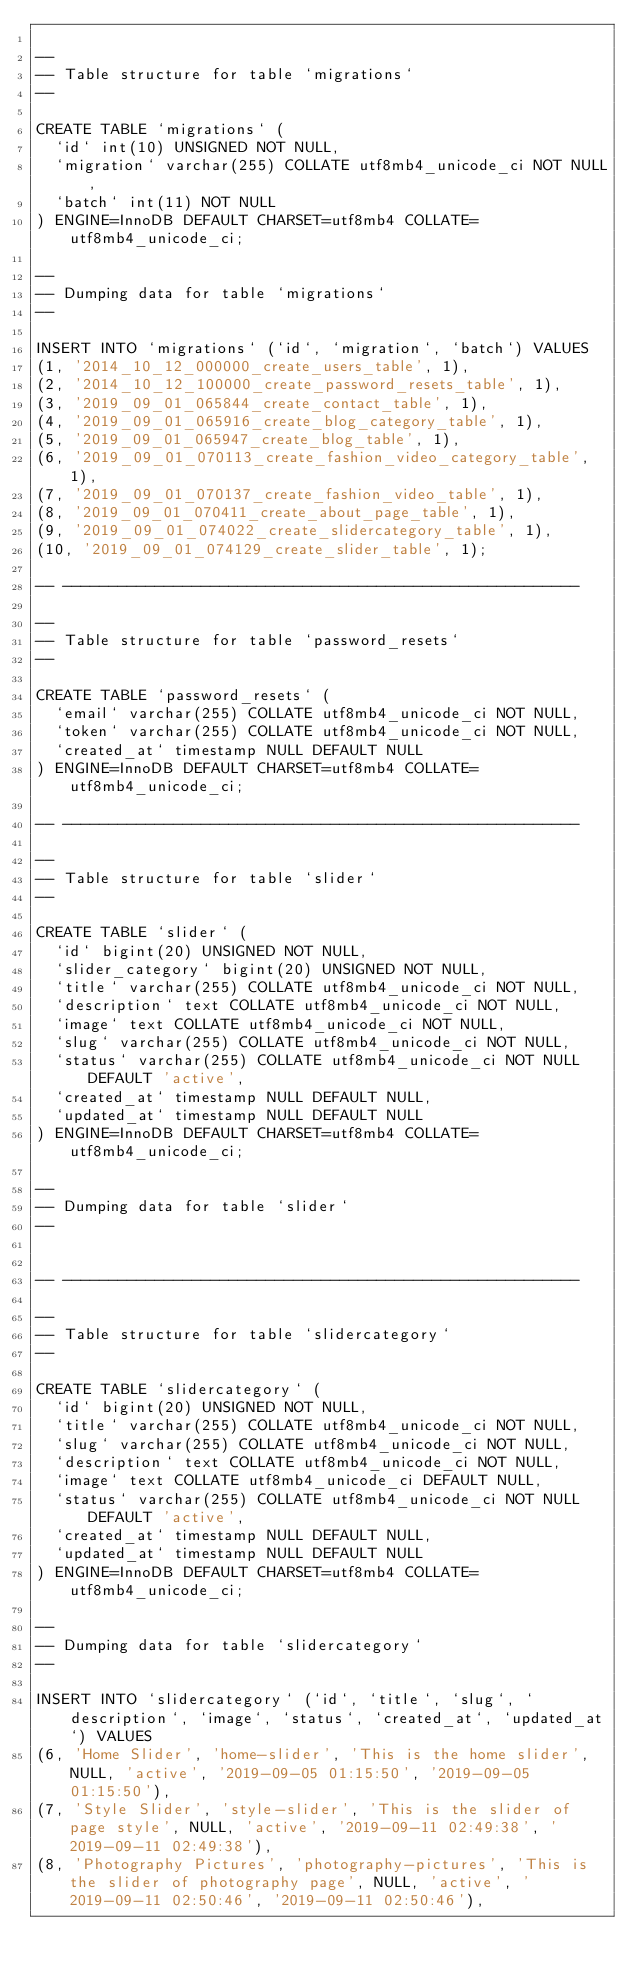<code> <loc_0><loc_0><loc_500><loc_500><_SQL_>
--
-- Table structure for table `migrations`
--

CREATE TABLE `migrations` (
  `id` int(10) UNSIGNED NOT NULL,
  `migration` varchar(255) COLLATE utf8mb4_unicode_ci NOT NULL,
  `batch` int(11) NOT NULL
) ENGINE=InnoDB DEFAULT CHARSET=utf8mb4 COLLATE=utf8mb4_unicode_ci;

--
-- Dumping data for table `migrations`
--

INSERT INTO `migrations` (`id`, `migration`, `batch`) VALUES
(1, '2014_10_12_000000_create_users_table', 1),
(2, '2014_10_12_100000_create_password_resets_table', 1),
(3, '2019_09_01_065844_create_contact_table', 1),
(4, '2019_09_01_065916_create_blog_category_table', 1),
(5, '2019_09_01_065947_create_blog_table', 1),
(6, '2019_09_01_070113_create_fashion_video_category_table', 1),
(7, '2019_09_01_070137_create_fashion_video_table', 1),
(8, '2019_09_01_070411_create_about_page_table', 1),
(9, '2019_09_01_074022_create_slidercategory_table', 1),
(10, '2019_09_01_074129_create_slider_table', 1);

-- --------------------------------------------------------

--
-- Table structure for table `password_resets`
--

CREATE TABLE `password_resets` (
  `email` varchar(255) COLLATE utf8mb4_unicode_ci NOT NULL,
  `token` varchar(255) COLLATE utf8mb4_unicode_ci NOT NULL,
  `created_at` timestamp NULL DEFAULT NULL
) ENGINE=InnoDB DEFAULT CHARSET=utf8mb4 COLLATE=utf8mb4_unicode_ci;

-- --------------------------------------------------------

--
-- Table structure for table `slider`
--

CREATE TABLE `slider` (
  `id` bigint(20) UNSIGNED NOT NULL,
  `slider_category` bigint(20) UNSIGNED NOT NULL,
  `title` varchar(255) COLLATE utf8mb4_unicode_ci NOT NULL,
  `description` text COLLATE utf8mb4_unicode_ci NOT NULL,
  `image` text COLLATE utf8mb4_unicode_ci NOT NULL,
  `slug` varchar(255) COLLATE utf8mb4_unicode_ci NOT NULL,
  `status` varchar(255) COLLATE utf8mb4_unicode_ci NOT NULL DEFAULT 'active',
  `created_at` timestamp NULL DEFAULT NULL,
  `updated_at` timestamp NULL DEFAULT NULL
) ENGINE=InnoDB DEFAULT CHARSET=utf8mb4 COLLATE=utf8mb4_unicode_ci;

--
-- Dumping data for table `slider`
--


-- --------------------------------------------------------

--
-- Table structure for table `slidercategory`
--

CREATE TABLE `slidercategory` (
  `id` bigint(20) UNSIGNED NOT NULL,
  `title` varchar(255) COLLATE utf8mb4_unicode_ci NOT NULL,
  `slug` varchar(255) COLLATE utf8mb4_unicode_ci NOT NULL,
  `description` text COLLATE utf8mb4_unicode_ci NOT NULL,
  `image` text COLLATE utf8mb4_unicode_ci DEFAULT NULL,
  `status` varchar(255) COLLATE utf8mb4_unicode_ci NOT NULL DEFAULT 'active',
  `created_at` timestamp NULL DEFAULT NULL,
  `updated_at` timestamp NULL DEFAULT NULL
) ENGINE=InnoDB DEFAULT CHARSET=utf8mb4 COLLATE=utf8mb4_unicode_ci;

--
-- Dumping data for table `slidercategory`
--

INSERT INTO `slidercategory` (`id`, `title`, `slug`, `description`, `image`, `status`, `created_at`, `updated_at`) VALUES
(6, 'Home Slider', 'home-slider', 'This is the home slider', NULL, 'active', '2019-09-05 01:15:50', '2019-09-05 01:15:50'),
(7, 'Style Slider', 'style-slider', 'This is the slider of page style', NULL, 'active', '2019-09-11 02:49:38', '2019-09-11 02:49:38'),
(8, 'Photography Pictures', 'photography-pictures', 'This is the slider of photography page', NULL, 'active', '2019-09-11 02:50:46', '2019-09-11 02:50:46'),</code> 